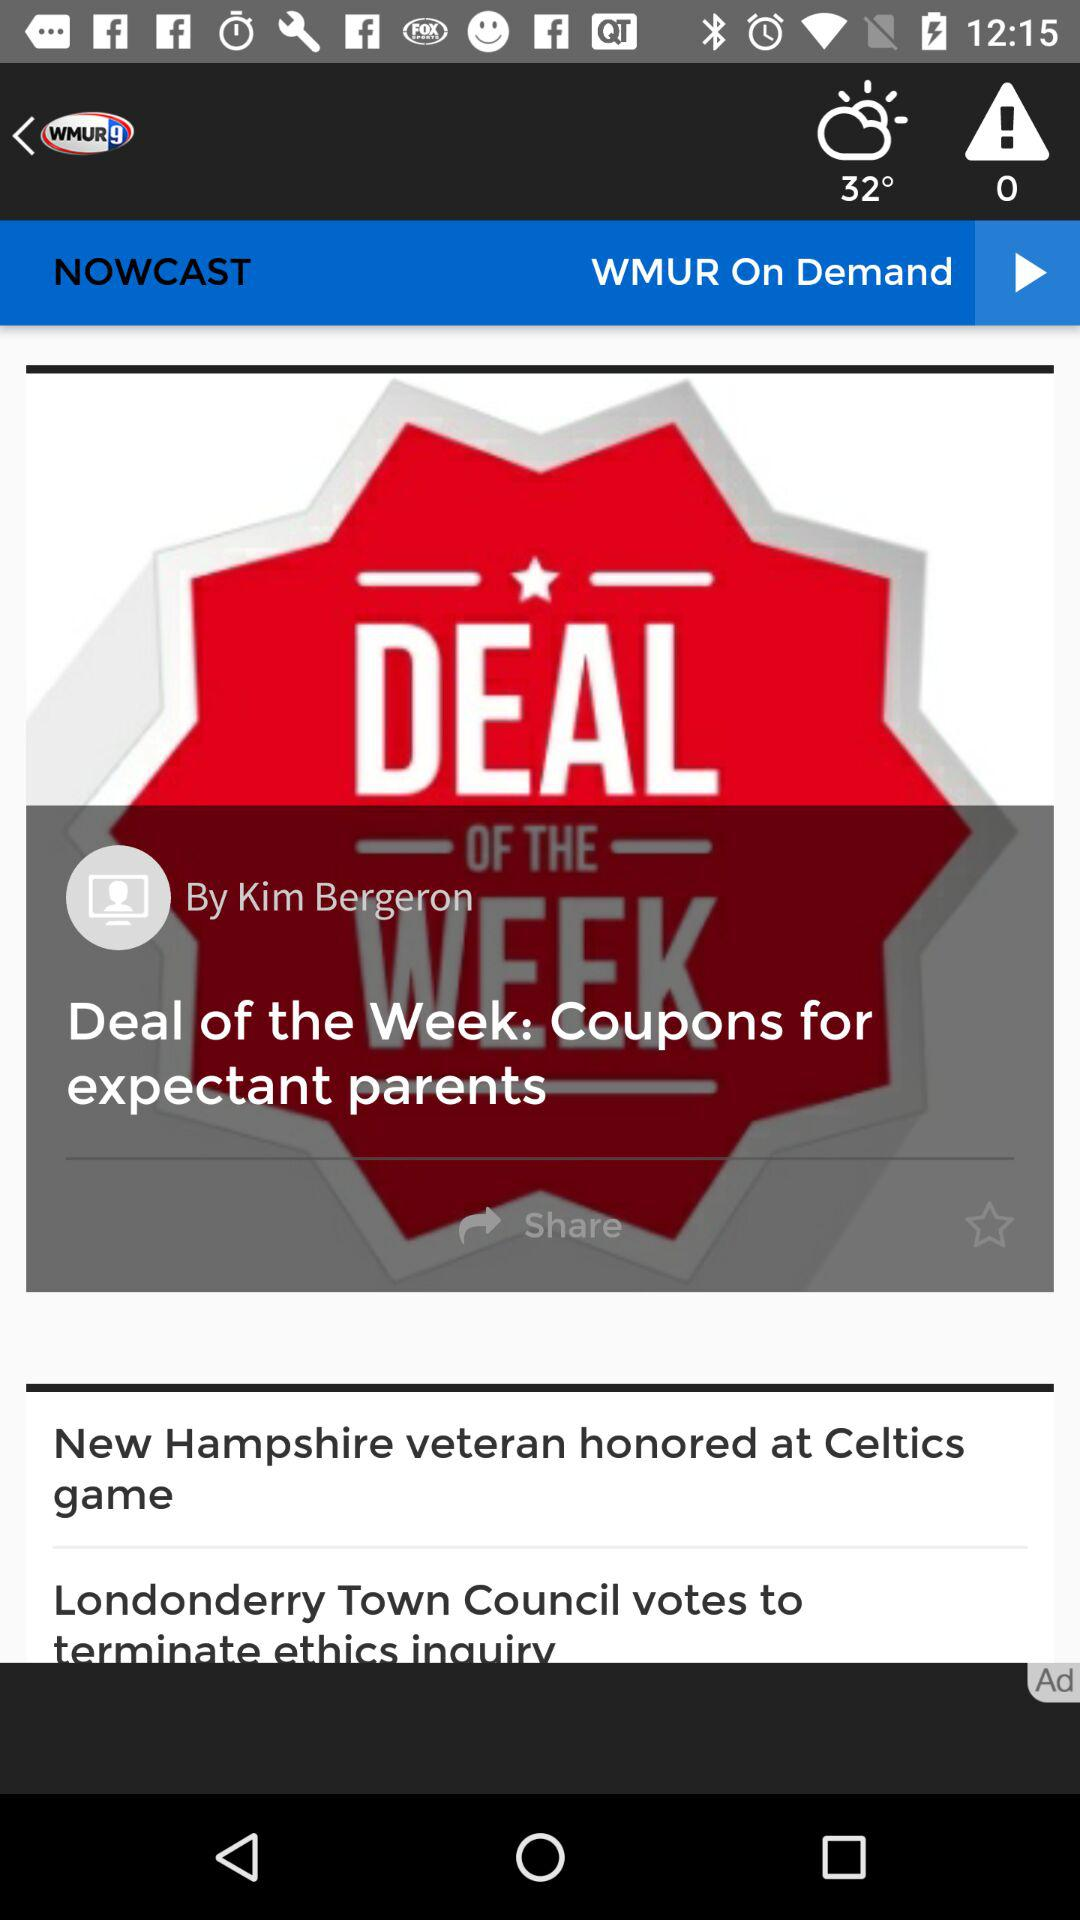What is the deal of the week? The deal of the week is "Coupons for expectant parents". 